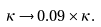Convert formula to latex. <formula><loc_0><loc_0><loc_500><loc_500>\kappa \rightarrow 0 . 0 9 \times \kappa .</formula> 